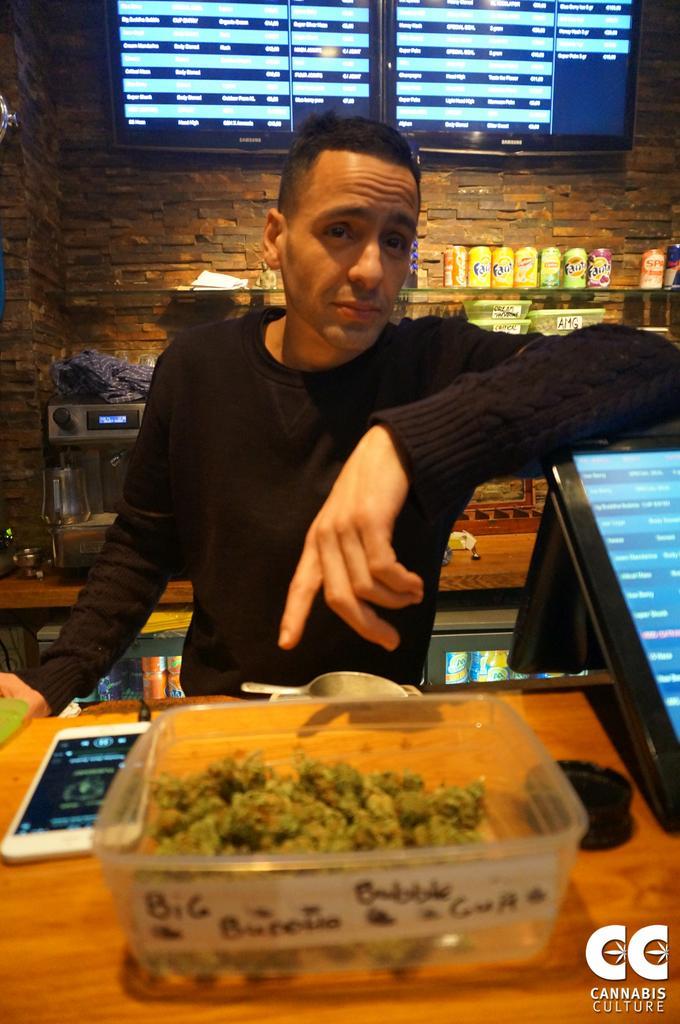Describe this image in one or two sentences. This is the man wearing black t-shirt and standing. This is the table with mobile phone and a box. This looks like a monitor screen. These are the tins and boxes placed on the rack. This looks like some machine. At background,I can see two screens attached to the wall. 